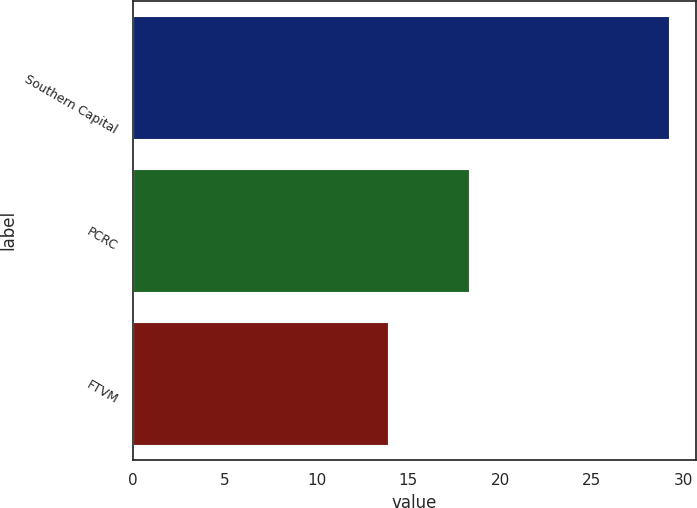<chart> <loc_0><loc_0><loc_500><loc_500><bar_chart><fcel>Southern Capital<fcel>PCRC<fcel>FTVM<nl><fcel>29.2<fcel>18.3<fcel>13.9<nl></chart> 